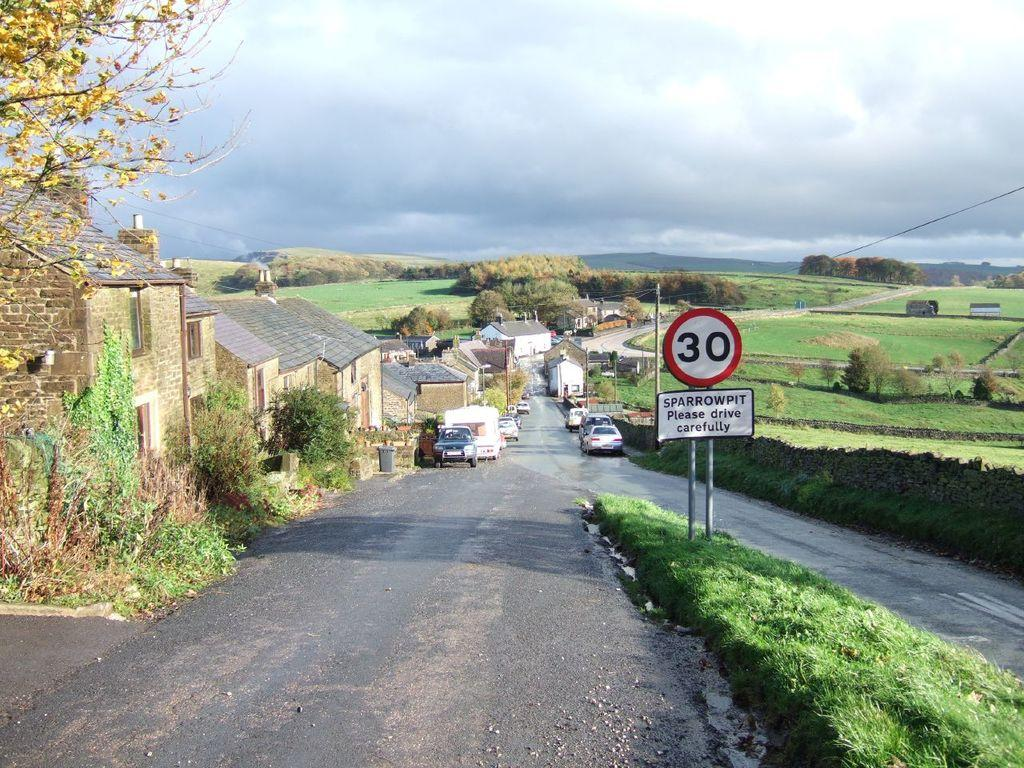<image>
Create a compact narrative representing the image presented. The speed sign at the entrance of Sparrowpit is listed at 30. 